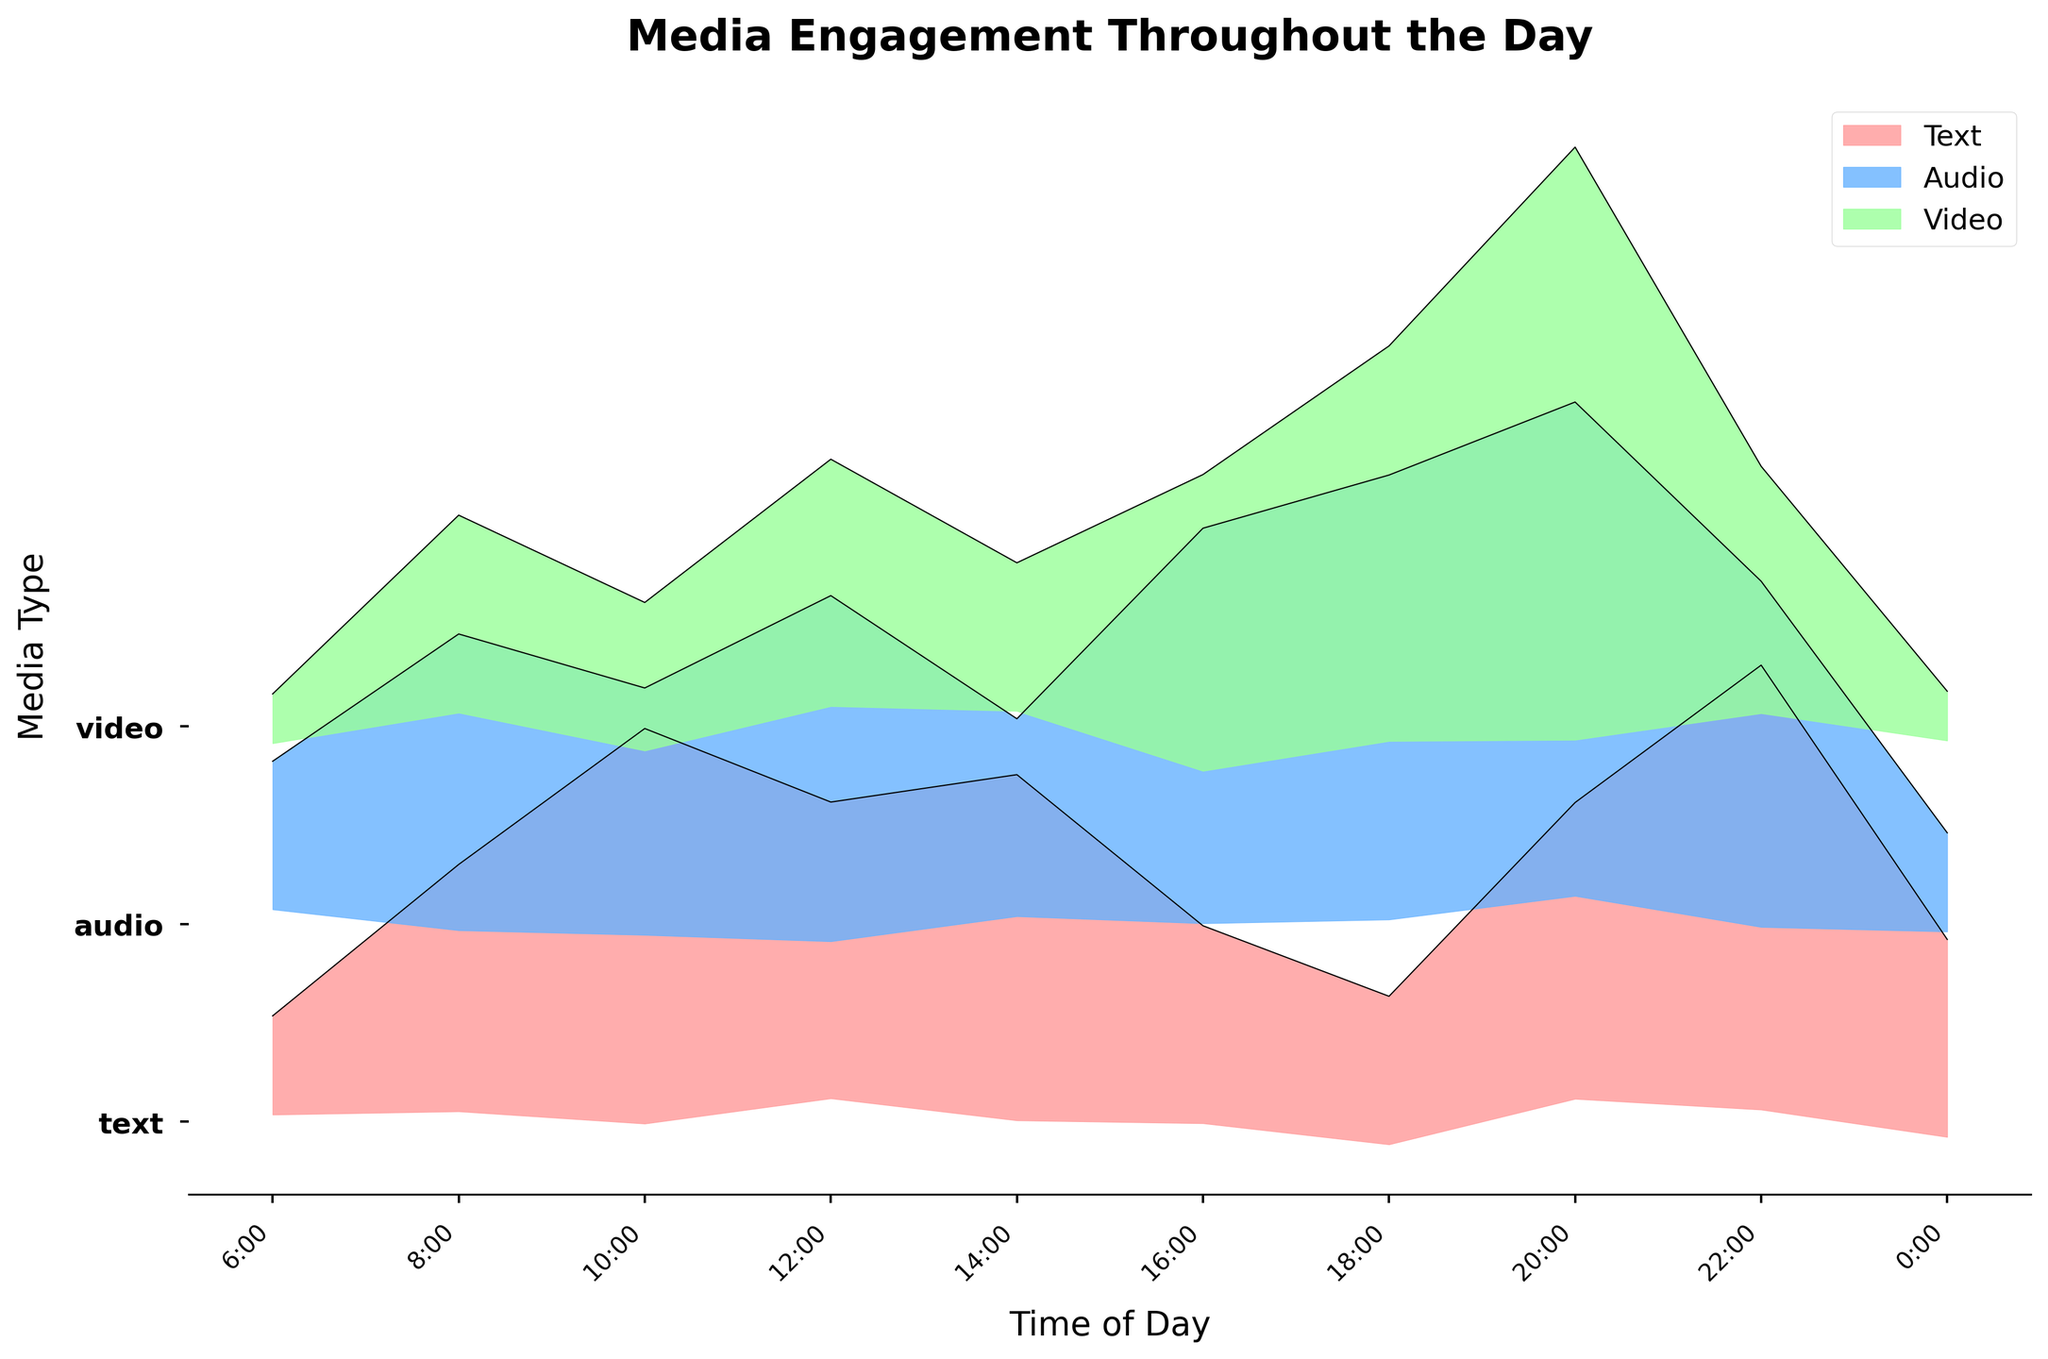What is the title of the plot? The plot title is located at the top of the figure in large bold font. It reads "Media Engagement Throughout the Day."
Answer: "Media Engagement Throughout the Day" How many media types are compared in the plot? The y-axis of the plot, labeled "Media Type", shows three equally spaced tick labels: text, audio, and video.
Answer: Three (text, audio, video) What media type has the highest engagement during Prime Time (20:00)? At 20:00, the plot's ridgeline for video is the largest compared to text and audio, indicating higher engagement.
Answer: Video What are the engagement levels for text media at 10:00? The engagement level for text at 10:00 can be read directly from the plot near the corresponding y-axis tick for "text".
Answer: 40 At which time of day does audio have the highest engagement? By examining the ridgelines, the highest peak for audio occurs at 20:00.
Answer: 20:00 (Prime Time) Is video engagement higher during the Evening Commute or during Dinner Time? Comparing the ridgelines for video at 16:00 and 18:00, the height at 18:00 is higher.
Answer: Dinner Time Which media type has the lowest engagement at Bedtime (22:00)? The ridgeline for video at 22:00 is the shortest compared to text and audio.
Answer: Video During which time is text engagement higher: Commute Time (8:00) or Bedtime (22:00)? The ridgeline for text at 22:00 is higher compared to the one at 8:00.
Answer: Bedtime What is the engagement difference between audio and video during Dinner Time (18:00)? The ridgelines indicate the engagement levels are 45 for audio and 40 for video. Subtracting these gives 5.
Answer: 5 How does engagement with text media change from Morning News (6:00) to Lunch Hour (12:00)? The ridgeline for text shows an increase from 10 at 6:00 to 30 at 12:00.
Answer: It increases by 20 